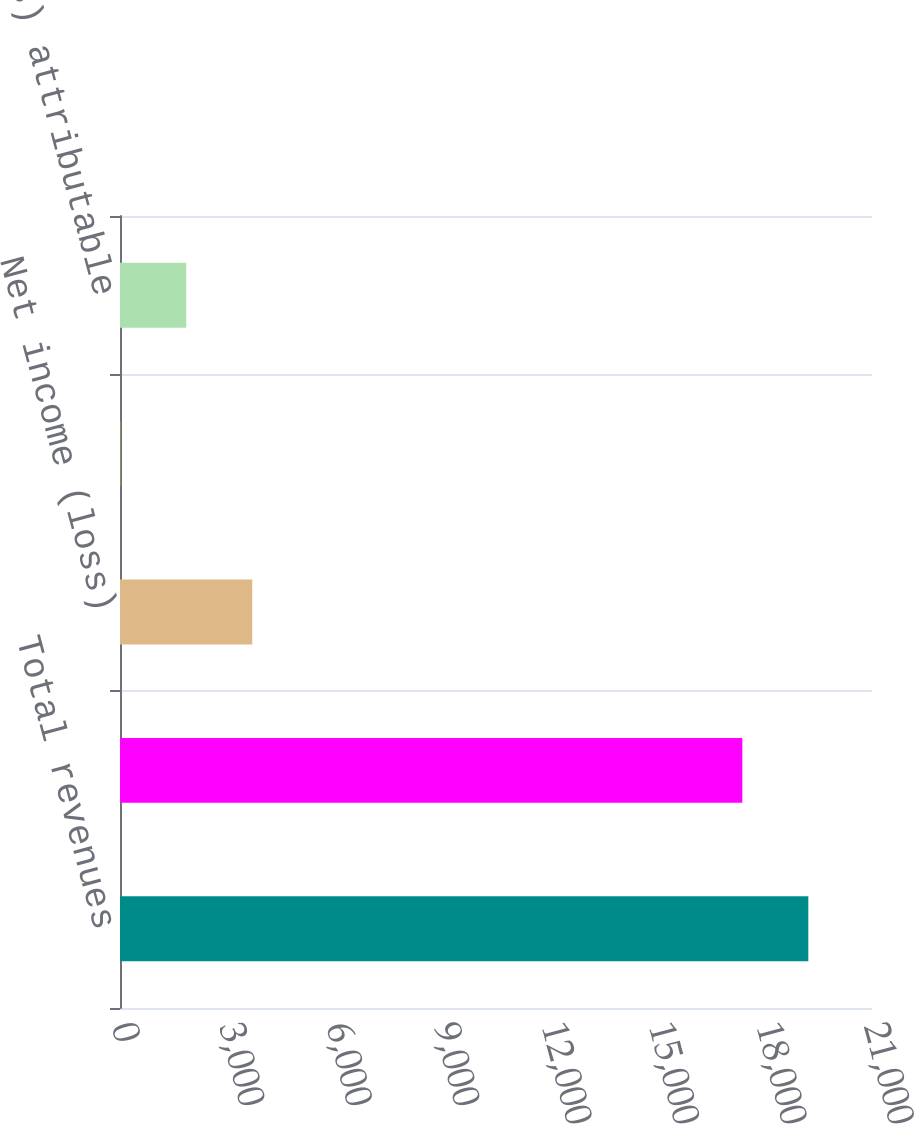<chart> <loc_0><loc_0><loc_500><loc_500><bar_chart><fcel>Total revenues<fcel>Total benefits and expenses<fcel>Net income (loss)<fcel>Less Income attributable to<fcel>Net income (loss) attributable<nl><fcel>19221.5<fcel>17379<fcel>3692<fcel>7<fcel>1849.5<nl></chart> 